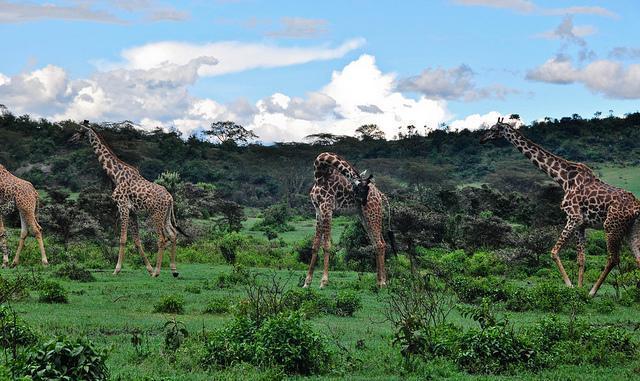How many giraffes?
Give a very brief answer. 4. How many animals are here?
Give a very brief answer. 4. How many giraffes are in the photo?
Give a very brief answer. 4. 